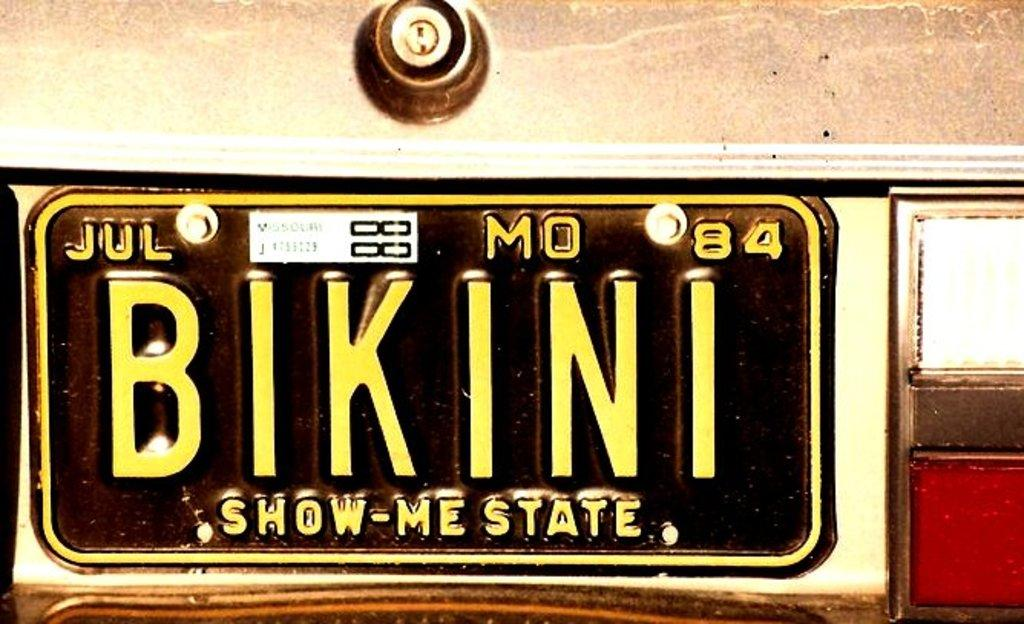<image>
Give a short and clear explanation of the subsequent image. The vintage car tag from Missouri, the show me state, reads BIKINI. 